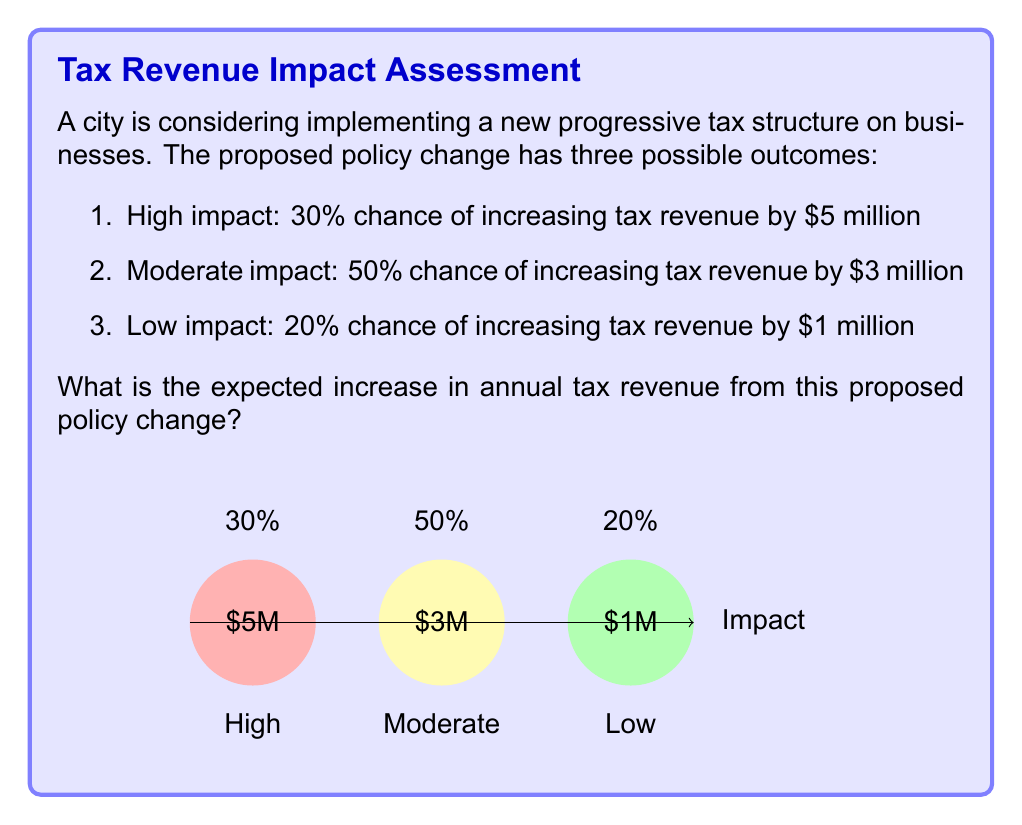Solve this math problem. To calculate the expected increase in tax revenue, we need to use the concept of expected value. The expected value is the sum of each possible outcome multiplied by its probability.

Let's break it down step by step:

1) For the high impact scenario:
   Probability = 0.30
   Revenue increase = $5 million
   Expected value = $5 million × 0.30 = $1.5 million

2) For the moderate impact scenario:
   Probability = 0.50
   Revenue increase = $3 million
   Expected value = $3 million × 0.50 = $1.5 million

3) For the low impact scenario:
   Probability = 0.20
   Revenue increase = $1 million
   Expected value = $1 million × 0.20 = $0.2 million

4) The total expected value is the sum of these individual expected values:

   $E(\text{Revenue Increase}) = (5 \times 0.30) + (3 \times 0.50) + (1 \times 0.20)$
   
   $E(\text{Revenue Increase}) = 1.5 + 1.5 + 0.2 = 3.2$

Therefore, the expected increase in annual tax revenue from this proposed policy change is $3.2 million.

This calculation provides a quantitative basis for policy decision-making, allowing government officials to assess the potential fiscal impact of the proposed tax structure change.
Answer: $3.2 million 